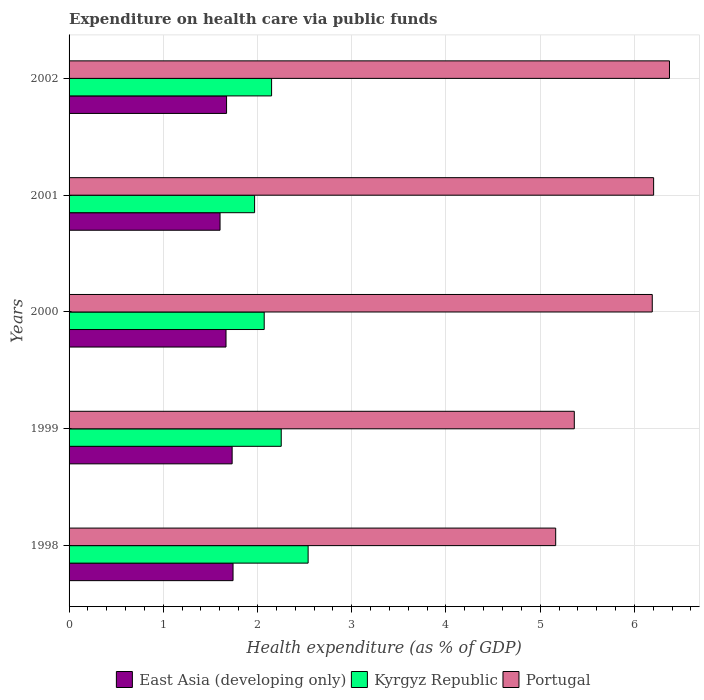How many groups of bars are there?
Keep it short and to the point. 5. Are the number of bars on each tick of the Y-axis equal?
Provide a short and direct response. Yes. How many bars are there on the 1st tick from the top?
Provide a succinct answer. 3. In how many cases, is the number of bars for a given year not equal to the number of legend labels?
Provide a succinct answer. 0. What is the expenditure made on health care in East Asia (developing only) in 1999?
Provide a succinct answer. 1.73. Across all years, what is the maximum expenditure made on health care in Portugal?
Keep it short and to the point. 6.37. Across all years, what is the minimum expenditure made on health care in Kyrgyz Republic?
Give a very brief answer. 1.97. What is the total expenditure made on health care in Kyrgyz Republic in the graph?
Offer a very short reply. 10.98. What is the difference between the expenditure made on health care in Portugal in 1999 and that in 2002?
Provide a short and direct response. -1.01. What is the difference between the expenditure made on health care in Kyrgyz Republic in 1998 and the expenditure made on health care in Portugal in 2001?
Ensure brevity in your answer.  -3.67. What is the average expenditure made on health care in East Asia (developing only) per year?
Offer a terse response. 1.68. In the year 2001, what is the difference between the expenditure made on health care in Kyrgyz Republic and expenditure made on health care in East Asia (developing only)?
Provide a succinct answer. 0.37. What is the ratio of the expenditure made on health care in East Asia (developing only) in 1998 to that in 1999?
Your response must be concise. 1.01. Is the difference between the expenditure made on health care in Kyrgyz Republic in 2000 and 2002 greater than the difference between the expenditure made on health care in East Asia (developing only) in 2000 and 2002?
Provide a succinct answer. No. What is the difference between the highest and the second highest expenditure made on health care in East Asia (developing only)?
Your answer should be compact. 0.01. What is the difference between the highest and the lowest expenditure made on health care in Portugal?
Offer a terse response. 1.21. In how many years, is the expenditure made on health care in Portugal greater than the average expenditure made on health care in Portugal taken over all years?
Ensure brevity in your answer.  3. Is the sum of the expenditure made on health care in Portugal in 1999 and 2000 greater than the maximum expenditure made on health care in East Asia (developing only) across all years?
Provide a short and direct response. Yes. What does the 1st bar from the top in 2001 represents?
Ensure brevity in your answer.  Portugal. What does the 1st bar from the bottom in 1999 represents?
Your answer should be compact. East Asia (developing only). Is it the case that in every year, the sum of the expenditure made on health care in Portugal and expenditure made on health care in Kyrgyz Republic is greater than the expenditure made on health care in East Asia (developing only)?
Make the answer very short. Yes. Are all the bars in the graph horizontal?
Your answer should be compact. Yes. What is the difference between two consecutive major ticks on the X-axis?
Your response must be concise. 1. Are the values on the major ticks of X-axis written in scientific E-notation?
Make the answer very short. No. Does the graph contain grids?
Your answer should be very brief. Yes. What is the title of the graph?
Provide a short and direct response. Expenditure on health care via public funds. What is the label or title of the X-axis?
Keep it short and to the point. Health expenditure (as % of GDP). What is the Health expenditure (as % of GDP) in East Asia (developing only) in 1998?
Provide a short and direct response. 1.74. What is the Health expenditure (as % of GDP) in Kyrgyz Republic in 1998?
Offer a terse response. 2.54. What is the Health expenditure (as % of GDP) in Portugal in 1998?
Ensure brevity in your answer.  5.16. What is the Health expenditure (as % of GDP) of East Asia (developing only) in 1999?
Make the answer very short. 1.73. What is the Health expenditure (as % of GDP) in Kyrgyz Republic in 1999?
Keep it short and to the point. 2.25. What is the Health expenditure (as % of GDP) of Portugal in 1999?
Provide a short and direct response. 5.36. What is the Health expenditure (as % of GDP) of East Asia (developing only) in 2000?
Your response must be concise. 1.67. What is the Health expenditure (as % of GDP) of Kyrgyz Republic in 2000?
Provide a succinct answer. 2.07. What is the Health expenditure (as % of GDP) of Portugal in 2000?
Your answer should be compact. 6.19. What is the Health expenditure (as % of GDP) in East Asia (developing only) in 2001?
Give a very brief answer. 1.6. What is the Health expenditure (as % of GDP) in Kyrgyz Republic in 2001?
Your answer should be compact. 1.97. What is the Health expenditure (as % of GDP) of Portugal in 2001?
Offer a very short reply. 6.2. What is the Health expenditure (as % of GDP) in East Asia (developing only) in 2002?
Provide a succinct answer. 1.67. What is the Health expenditure (as % of GDP) in Kyrgyz Republic in 2002?
Provide a short and direct response. 2.15. What is the Health expenditure (as % of GDP) in Portugal in 2002?
Provide a succinct answer. 6.37. Across all years, what is the maximum Health expenditure (as % of GDP) of East Asia (developing only)?
Make the answer very short. 1.74. Across all years, what is the maximum Health expenditure (as % of GDP) in Kyrgyz Republic?
Provide a succinct answer. 2.54. Across all years, what is the maximum Health expenditure (as % of GDP) in Portugal?
Make the answer very short. 6.37. Across all years, what is the minimum Health expenditure (as % of GDP) in East Asia (developing only)?
Offer a very short reply. 1.6. Across all years, what is the minimum Health expenditure (as % of GDP) in Kyrgyz Republic?
Make the answer very short. 1.97. Across all years, what is the minimum Health expenditure (as % of GDP) in Portugal?
Make the answer very short. 5.16. What is the total Health expenditure (as % of GDP) in East Asia (developing only) in the graph?
Your answer should be compact. 8.41. What is the total Health expenditure (as % of GDP) of Kyrgyz Republic in the graph?
Your answer should be very brief. 10.98. What is the total Health expenditure (as % of GDP) in Portugal in the graph?
Provide a short and direct response. 29.29. What is the difference between the Health expenditure (as % of GDP) of East Asia (developing only) in 1998 and that in 1999?
Offer a very short reply. 0.01. What is the difference between the Health expenditure (as % of GDP) in Kyrgyz Republic in 1998 and that in 1999?
Offer a very short reply. 0.29. What is the difference between the Health expenditure (as % of GDP) of Portugal in 1998 and that in 1999?
Keep it short and to the point. -0.2. What is the difference between the Health expenditure (as % of GDP) in East Asia (developing only) in 1998 and that in 2000?
Provide a succinct answer. 0.07. What is the difference between the Health expenditure (as % of GDP) in Kyrgyz Republic in 1998 and that in 2000?
Ensure brevity in your answer.  0.47. What is the difference between the Health expenditure (as % of GDP) in Portugal in 1998 and that in 2000?
Keep it short and to the point. -1.02. What is the difference between the Health expenditure (as % of GDP) of East Asia (developing only) in 1998 and that in 2001?
Your answer should be compact. 0.14. What is the difference between the Health expenditure (as % of GDP) of Kyrgyz Republic in 1998 and that in 2001?
Offer a terse response. 0.57. What is the difference between the Health expenditure (as % of GDP) in Portugal in 1998 and that in 2001?
Offer a terse response. -1.04. What is the difference between the Health expenditure (as % of GDP) of East Asia (developing only) in 1998 and that in 2002?
Offer a terse response. 0.07. What is the difference between the Health expenditure (as % of GDP) of Kyrgyz Republic in 1998 and that in 2002?
Make the answer very short. 0.39. What is the difference between the Health expenditure (as % of GDP) of Portugal in 1998 and that in 2002?
Offer a very short reply. -1.21. What is the difference between the Health expenditure (as % of GDP) of East Asia (developing only) in 1999 and that in 2000?
Your answer should be very brief. 0.07. What is the difference between the Health expenditure (as % of GDP) in Kyrgyz Republic in 1999 and that in 2000?
Give a very brief answer. 0.18. What is the difference between the Health expenditure (as % of GDP) of Portugal in 1999 and that in 2000?
Ensure brevity in your answer.  -0.83. What is the difference between the Health expenditure (as % of GDP) of East Asia (developing only) in 1999 and that in 2001?
Give a very brief answer. 0.13. What is the difference between the Health expenditure (as % of GDP) in Kyrgyz Republic in 1999 and that in 2001?
Provide a short and direct response. 0.28. What is the difference between the Health expenditure (as % of GDP) of Portugal in 1999 and that in 2001?
Offer a very short reply. -0.84. What is the difference between the Health expenditure (as % of GDP) in East Asia (developing only) in 1999 and that in 2002?
Provide a short and direct response. 0.06. What is the difference between the Health expenditure (as % of GDP) in Kyrgyz Republic in 1999 and that in 2002?
Make the answer very short. 0.1. What is the difference between the Health expenditure (as % of GDP) of Portugal in 1999 and that in 2002?
Your answer should be compact. -1.01. What is the difference between the Health expenditure (as % of GDP) of East Asia (developing only) in 2000 and that in 2001?
Give a very brief answer. 0.06. What is the difference between the Health expenditure (as % of GDP) of Kyrgyz Republic in 2000 and that in 2001?
Make the answer very short. 0.1. What is the difference between the Health expenditure (as % of GDP) of Portugal in 2000 and that in 2001?
Give a very brief answer. -0.01. What is the difference between the Health expenditure (as % of GDP) of East Asia (developing only) in 2000 and that in 2002?
Offer a terse response. -0.01. What is the difference between the Health expenditure (as % of GDP) of Kyrgyz Republic in 2000 and that in 2002?
Keep it short and to the point. -0.08. What is the difference between the Health expenditure (as % of GDP) of Portugal in 2000 and that in 2002?
Offer a terse response. -0.18. What is the difference between the Health expenditure (as % of GDP) of East Asia (developing only) in 2001 and that in 2002?
Keep it short and to the point. -0.07. What is the difference between the Health expenditure (as % of GDP) in Kyrgyz Republic in 2001 and that in 2002?
Provide a short and direct response. -0.18. What is the difference between the Health expenditure (as % of GDP) in Portugal in 2001 and that in 2002?
Provide a succinct answer. -0.17. What is the difference between the Health expenditure (as % of GDP) of East Asia (developing only) in 1998 and the Health expenditure (as % of GDP) of Kyrgyz Republic in 1999?
Offer a terse response. -0.51. What is the difference between the Health expenditure (as % of GDP) in East Asia (developing only) in 1998 and the Health expenditure (as % of GDP) in Portugal in 1999?
Offer a very short reply. -3.62. What is the difference between the Health expenditure (as % of GDP) of Kyrgyz Republic in 1998 and the Health expenditure (as % of GDP) of Portugal in 1999?
Your response must be concise. -2.82. What is the difference between the Health expenditure (as % of GDP) in East Asia (developing only) in 1998 and the Health expenditure (as % of GDP) in Kyrgyz Republic in 2000?
Provide a succinct answer. -0.33. What is the difference between the Health expenditure (as % of GDP) of East Asia (developing only) in 1998 and the Health expenditure (as % of GDP) of Portugal in 2000?
Ensure brevity in your answer.  -4.45. What is the difference between the Health expenditure (as % of GDP) of Kyrgyz Republic in 1998 and the Health expenditure (as % of GDP) of Portugal in 2000?
Give a very brief answer. -3.65. What is the difference between the Health expenditure (as % of GDP) in East Asia (developing only) in 1998 and the Health expenditure (as % of GDP) in Kyrgyz Republic in 2001?
Keep it short and to the point. -0.23. What is the difference between the Health expenditure (as % of GDP) in East Asia (developing only) in 1998 and the Health expenditure (as % of GDP) in Portugal in 2001?
Offer a terse response. -4.46. What is the difference between the Health expenditure (as % of GDP) in Kyrgyz Republic in 1998 and the Health expenditure (as % of GDP) in Portugal in 2001?
Give a very brief answer. -3.67. What is the difference between the Health expenditure (as % of GDP) of East Asia (developing only) in 1998 and the Health expenditure (as % of GDP) of Kyrgyz Republic in 2002?
Give a very brief answer. -0.41. What is the difference between the Health expenditure (as % of GDP) in East Asia (developing only) in 1998 and the Health expenditure (as % of GDP) in Portugal in 2002?
Make the answer very short. -4.63. What is the difference between the Health expenditure (as % of GDP) in Kyrgyz Republic in 1998 and the Health expenditure (as % of GDP) in Portugal in 2002?
Keep it short and to the point. -3.83. What is the difference between the Health expenditure (as % of GDP) of East Asia (developing only) in 1999 and the Health expenditure (as % of GDP) of Kyrgyz Republic in 2000?
Your response must be concise. -0.34. What is the difference between the Health expenditure (as % of GDP) in East Asia (developing only) in 1999 and the Health expenditure (as % of GDP) in Portugal in 2000?
Make the answer very short. -4.46. What is the difference between the Health expenditure (as % of GDP) in Kyrgyz Republic in 1999 and the Health expenditure (as % of GDP) in Portugal in 2000?
Make the answer very short. -3.94. What is the difference between the Health expenditure (as % of GDP) of East Asia (developing only) in 1999 and the Health expenditure (as % of GDP) of Kyrgyz Republic in 2001?
Provide a short and direct response. -0.24. What is the difference between the Health expenditure (as % of GDP) of East Asia (developing only) in 1999 and the Health expenditure (as % of GDP) of Portugal in 2001?
Keep it short and to the point. -4.47. What is the difference between the Health expenditure (as % of GDP) in Kyrgyz Republic in 1999 and the Health expenditure (as % of GDP) in Portugal in 2001?
Your answer should be very brief. -3.95. What is the difference between the Health expenditure (as % of GDP) of East Asia (developing only) in 1999 and the Health expenditure (as % of GDP) of Kyrgyz Republic in 2002?
Provide a short and direct response. -0.42. What is the difference between the Health expenditure (as % of GDP) in East Asia (developing only) in 1999 and the Health expenditure (as % of GDP) in Portugal in 2002?
Provide a short and direct response. -4.64. What is the difference between the Health expenditure (as % of GDP) of Kyrgyz Republic in 1999 and the Health expenditure (as % of GDP) of Portugal in 2002?
Keep it short and to the point. -4.12. What is the difference between the Health expenditure (as % of GDP) in East Asia (developing only) in 2000 and the Health expenditure (as % of GDP) in Kyrgyz Republic in 2001?
Offer a very short reply. -0.3. What is the difference between the Health expenditure (as % of GDP) of East Asia (developing only) in 2000 and the Health expenditure (as % of GDP) of Portugal in 2001?
Keep it short and to the point. -4.54. What is the difference between the Health expenditure (as % of GDP) in Kyrgyz Republic in 2000 and the Health expenditure (as % of GDP) in Portugal in 2001?
Make the answer very short. -4.13. What is the difference between the Health expenditure (as % of GDP) in East Asia (developing only) in 2000 and the Health expenditure (as % of GDP) in Kyrgyz Republic in 2002?
Your response must be concise. -0.48. What is the difference between the Health expenditure (as % of GDP) of East Asia (developing only) in 2000 and the Health expenditure (as % of GDP) of Portugal in 2002?
Keep it short and to the point. -4.71. What is the difference between the Health expenditure (as % of GDP) of Kyrgyz Republic in 2000 and the Health expenditure (as % of GDP) of Portugal in 2002?
Provide a succinct answer. -4.3. What is the difference between the Health expenditure (as % of GDP) of East Asia (developing only) in 2001 and the Health expenditure (as % of GDP) of Kyrgyz Republic in 2002?
Your response must be concise. -0.55. What is the difference between the Health expenditure (as % of GDP) in East Asia (developing only) in 2001 and the Health expenditure (as % of GDP) in Portugal in 2002?
Keep it short and to the point. -4.77. What is the difference between the Health expenditure (as % of GDP) of Kyrgyz Republic in 2001 and the Health expenditure (as % of GDP) of Portugal in 2002?
Keep it short and to the point. -4.4. What is the average Health expenditure (as % of GDP) of East Asia (developing only) per year?
Your response must be concise. 1.68. What is the average Health expenditure (as % of GDP) in Kyrgyz Republic per year?
Your answer should be compact. 2.2. What is the average Health expenditure (as % of GDP) in Portugal per year?
Ensure brevity in your answer.  5.86. In the year 1998, what is the difference between the Health expenditure (as % of GDP) in East Asia (developing only) and Health expenditure (as % of GDP) in Kyrgyz Republic?
Offer a very short reply. -0.8. In the year 1998, what is the difference between the Health expenditure (as % of GDP) of East Asia (developing only) and Health expenditure (as % of GDP) of Portugal?
Give a very brief answer. -3.42. In the year 1998, what is the difference between the Health expenditure (as % of GDP) of Kyrgyz Republic and Health expenditure (as % of GDP) of Portugal?
Your response must be concise. -2.63. In the year 1999, what is the difference between the Health expenditure (as % of GDP) in East Asia (developing only) and Health expenditure (as % of GDP) in Kyrgyz Republic?
Give a very brief answer. -0.52. In the year 1999, what is the difference between the Health expenditure (as % of GDP) in East Asia (developing only) and Health expenditure (as % of GDP) in Portugal?
Your response must be concise. -3.63. In the year 1999, what is the difference between the Health expenditure (as % of GDP) of Kyrgyz Republic and Health expenditure (as % of GDP) of Portugal?
Give a very brief answer. -3.11. In the year 2000, what is the difference between the Health expenditure (as % of GDP) in East Asia (developing only) and Health expenditure (as % of GDP) in Kyrgyz Republic?
Keep it short and to the point. -0.41. In the year 2000, what is the difference between the Health expenditure (as % of GDP) of East Asia (developing only) and Health expenditure (as % of GDP) of Portugal?
Your answer should be very brief. -4.52. In the year 2000, what is the difference between the Health expenditure (as % of GDP) in Kyrgyz Republic and Health expenditure (as % of GDP) in Portugal?
Provide a succinct answer. -4.12. In the year 2001, what is the difference between the Health expenditure (as % of GDP) in East Asia (developing only) and Health expenditure (as % of GDP) in Kyrgyz Republic?
Your answer should be compact. -0.37. In the year 2001, what is the difference between the Health expenditure (as % of GDP) in East Asia (developing only) and Health expenditure (as % of GDP) in Portugal?
Your answer should be compact. -4.6. In the year 2001, what is the difference between the Health expenditure (as % of GDP) in Kyrgyz Republic and Health expenditure (as % of GDP) in Portugal?
Give a very brief answer. -4.23. In the year 2002, what is the difference between the Health expenditure (as % of GDP) in East Asia (developing only) and Health expenditure (as % of GDP) in Kyrgyz Republic?
Offer a terse response. -0.48. In the year 2002, what is the difference between the Health expenditure (as % of GDP) of East Asia (developing only) and Health expenditure (as % of GDP) of Portugal?
Provide a short and direct response. -4.7. In the year 2002, what is the difference between the Health expenditure (as % of GDP) of Kyrgyz Republic and Health expenditure (as % of GDP) of Portugal?
Keep it short and to the point. -4.22. What is the ratio of the Health expenditure (as % of GDP) in East Asia (developing only) in 1998 to that in 1999?
Ensure brevity in your answer.  1.01. What is the ratio of the Health expenditure (as % of GDP) of Kyrgyz Republic in 1998 to that in 1999?
Your answer should be compact. 1.13. What is the ratio of the Health expenditure (as % of GDP) of Portugal in 1998 to that in 1999?
Provide a short and direct response. 0.96. What is the ratio of the Health expenditure (as % of GDP) in East Asia (developing only) in 1998 to that in 2000?
Provide a succinct answer. 1.04. What is the ratio of the Health expenditure (as % of GDP) in Kyrgyz Republic in 1998 to that in 2000?
Offer a terse response. 1.23. What is the ratio of the Health expenditure (as % of GDP) of Portugal in 1998 to that in 2000?
Your answer should be compact. 0.83. What is the ratio of the Health expenditure (as % of GDP) in East Asia (developing only) in 1998 to that in 2001?
Provide a short and direct response. 1.09. What is the ratio of the Health expenditure (as % of GDP) of Kyrgyz Republic in 1998 to that in 2001?
Give a very brief answer. 1.29. What is the ratio of the Health expenditure (as % of GDP) in Portugal in 1998 to that in 2001?
Ensure brevity in your answer.  0.83. What is the ratio of the Health expenditure (as % of GDP) of East Asia (developing only) in 1998 to that in 2002?
Your answer should be compact. 1.04. What is the ratio of the Health expenditure (as % of GDP) in Kyrgyz Republic in 1998 to that in 2002?
Offer a terse response. 1.18. What is the ratio of the Health expenditure (as % of GDP) in Portugal in 1998 to that in 2002?
Provide a succinct answer. 0.81. What is the ratio of the Health expenditure (as % of GDP) of East Asia (developing only) in 1999 to that in 2000?
Offer a very short reply. 1.04. What is the ratio of the Health expenditure (as % of GDP) of Kyrgyz Republic in 1999 to that in 2000?
Provide a succinct answer. 1.09. What is the ratio of the Health expenditure (as % of GDP) in Portugal in 1999 to that in 2000?
Make the answer very short. 0.87. What is the ratio of the Health expenditure (as % of GDP) of East Asia (developing only) in 1999 to that in 2001?
Provide a short and direct response. 1.08. What is the ratio of the Health expenditure (as % of GDP) of Kyrgyz Republic in 1999 to that in 2001?
Provide a short and direct response. 1.14. What is the ratio of the Health expenditure (as % of GDP) in Portugal in 1999 to that in 2001?
Your answer should be compact. 0.86. What is the ratio of the Health expenditure (as % of GDP) in East Asia (developing only) in 1999 to that in 2002?
Provide a succinct answer. 1.04. What is the ratio of the Health expenditure (as % of GDP) in Kyrgyz Republic in 1999 to that in 2002?
Provide a short and direct response. 1.05. What is the ratio of the Health expenditure (as % of GDP) of Portugal in 1999 to that in 2002?
Offer a very short reply. 0.84. What is the ratio of the Health expenditure (as % of GDP) of East Asia (developing only) in 2000 to that in 2001?
Your response must be concise. 1.04. What is the ratio of the Health expenditure (as % of GDP) in Kyrgyz Republic in 2000 to that in 2001?
Provide a short and direct response. 1.05. What is the ratio of the Health expenditure (as % of GDP) of Kyrgyz Republic in 2000 to that in 2002?
Your answer should be very brief. 0.96. What is the ratio of the Health expenditure (as % of GDP) in Portugal in 2000 to that in 2002?
Provide a short and direct response. 0.97. What is the ratio of the Health expenditure (as % of GDP) in East Asia (developing only) in 2001 to that in 2002?
Offer a very short reply. 0.96. What is the ratio of the Health expenditure (as % of GDP) of Kyrgyz Republic in 2001 to that in 2002?
Offer a terse response. 0.92. What is the ratio of the Health expenditure (as % of GDP) in Portugal in 2001 to that in 2002?
Provide a succinct answer. 0.97. What is the difference between the highest and the second highest Health expenditure (as % of GDP) of East Asia (developing only)?
Your response must be concise. 0.01. What is the difference between the highest and the second highest Health expenditure (as % of GDP) in Kyrgyz Republic?
Ensure brevity in your answer.  0.29. What is the difference between the highest and the second highest Health expenditure (as % of GDP) in Portugal?
Offer a terse response. 0.17. What is the difference between the highest and the lowest Health expenditure (as % of GDP) of East Asia (developing only)?
Provide a succinct answer. 0.14. What is the difference between the highest and the lowest Health expenditure (as % of GDP) of Kyrgyz Republic?
Your answer should be very brief. 0.57. What is the difference between the highest and the lowest Health expenditure (as % of GDP) in Portugal?
Give a very brief answer. 1.21. 